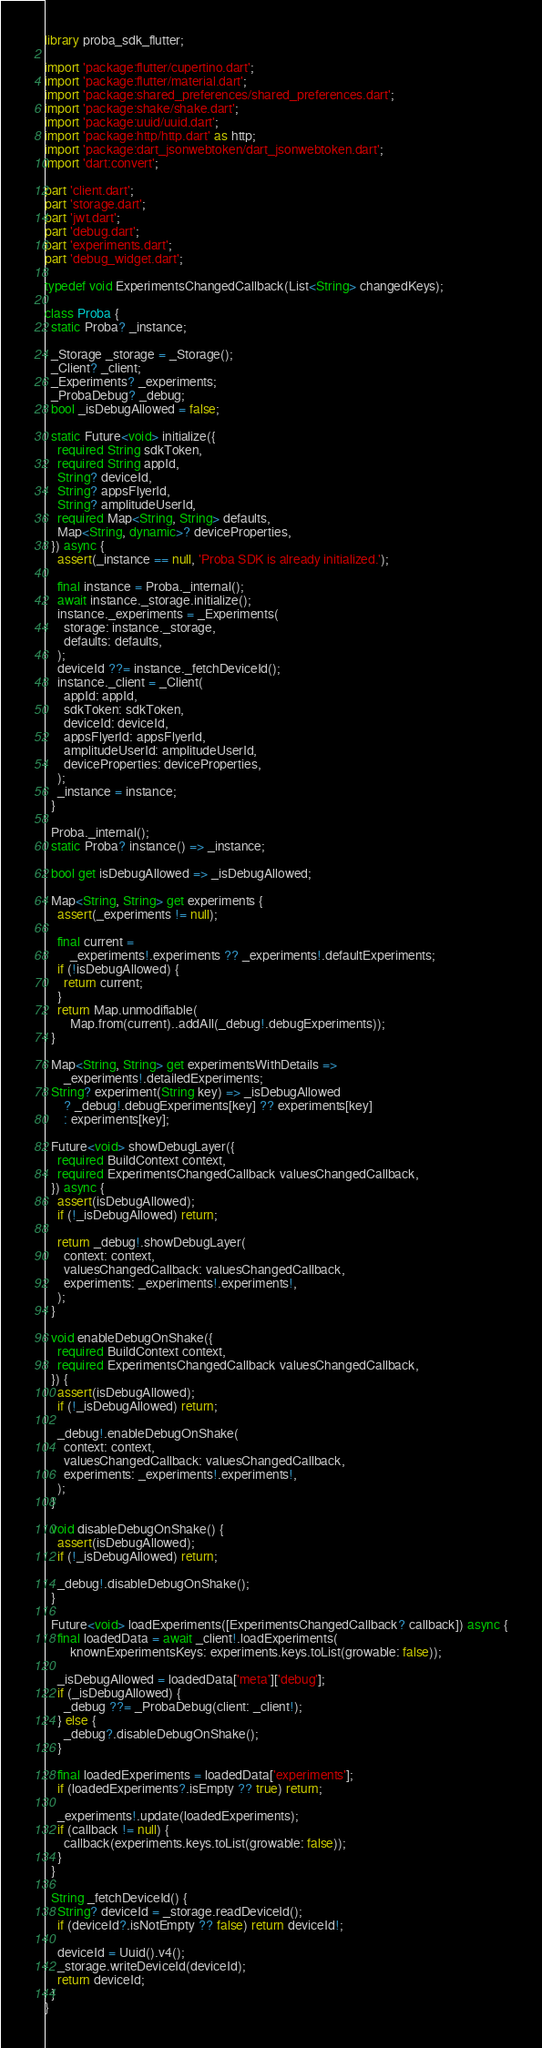Convert code to text. <code><loc_0><loc_0><loc_500><loc_500><_Dart_>library proba_sdk_flutter;

import 'package:flutter/cupertino.dart';
import 'package:flutter/material.dart';
import 'package:shared_preferences/shared_preferences.dart';
import 'package:shake/shake.dart';
import 'package:uuid/uuid.dart';
import 'package:http/http.dart' as http;
import 'package:dart_jsonwebtoken/dart_jsonwebtoken.dart';
import 'dart:convert';

part 'client.dart';
part 'storage.dart';
part 'jwt.dart';
part 'debug.dart';
part 'experiments.dart';
part 'debug_widget.dart';

typedef void ExperimentsChangedCallback(List<String> changedKeys);

class Proba {
  static Proba? _instance;

  _Storage _storage = _Storage();
  _Client? _client;
  _Experiments? _experiments;
  _ProbaDebug? _debug;
  bool _isDebugAllowed = false;

  static Future<void> initialize({
    required String sdkToken,
    required String appId,
    String? deviceId,
    String? appsFlyerId,
    String? amplitudeUserId,
    required Map<String, String> defaults,
    Map<String, dynamic>? deviceProperties,
  }) async {
    assert(_instance == null, 'Proba SDK is already initialized.');

    final instance = Proba._internal();
    await instance._storage.initialize();
    instance._experiments = _Experiments(
      storage: instance._storage,
      defaults: defaults,
    );
    deviceId ??= instance._fetchDeviceId();
    instance._client = _Client(
      appId: appId,
      sdkToken: sdkToken,
      deviceId: deviceId,
      appsFlyerId: appsFlyerId,
      amplitudeUserId: amplitudeUserId,
      deviceProperties: deviceProperties,
    );
    _instance = instance;
  }

  Proba._internal();
  static Proba? instance() => _instance;

  bool get isDebugAllowed => _isDebugAllowed;

  Map<String, String> get experiments {
    assert(_experiments != null);

    final current =
        _experiments!.experiments ?? _experiments!.defaultExperiments;
    if (!isDebugAllowed) {
      return current;
    }
    return Map.unmodifiable(
        Map.from(current)..addAll(_debug!.debugExperiments));
  }

  Map<String, String> get experimentsWithDetails =>
      _experiments!.detailedExperiments;
  String? experiment(String key) => _isDebugAllowed
      ? _debug!.debugExperiments[key] ?? experiments[key]
      : experiments[key];

  Future<void> showDebugLayer({
    required BuildContext context,
    required ExperimentsChangedCallback valuesChangedCallback,
  }) async {
    assert(isDebugAllowed);
    if (!_isDebugAllowed) return;

    return _debug!.showDebugLayer(
      context: context,
      valuesChangedCallback: valuesChangedCallback,
      experiments: _experiments!.experiments!,
    );
  }

  void enableDebugOnShake({
    required BuildContext context,
    required ExperimentsChangedCallback valuesChangedCallback,
  }) {
    assert(isDebugAllowed);
    if (!_isDebugAllowed) return;

    _debug!.enableDebugOnShake(
      context: context,
      valuesChangedCallback: valuesChangedCallback,
      experiments: _experiments!.experiments!,
    );
  }

  void disableDebugOnShake() {
    assert(isDebugAllowed);
    if (!_isDebugAllowed) return;

    _debug!.disableDebugOnShake();
  }

  Future<void> loadExperiments([ExperimentsChangedCallback? callback]) async {
    final loadedData = await _client!.loadExperiments(
        knownExperimentsKeys: experiments.keys.toList(growable: false));

    _isDebugAllowed = loadedData['meta']['debug'];
    if (_isDebugAllowed) {
      _debug ??= _ProbaDebug(client: _client!);
    } else {
      _debug?.disableDebugOnShake();
    }

    final loadedExperiments = loadedData['experiments'];
    if (loadedExperiments?.isEmpty ?? true) return;

    _experiments!.update(loadedExperiments);
    if (callback != null) {
      callback(experiments.keys.toList(growable: false));
    }
  }

  String _fetchDeviceId() {
    String? deviceId = _storage.readDeviceId();
    if (deviceId?.isNotEmpty ?? false) return deviceId!;

    deviceId = Uuid().v4();
    _storage.writeDeviceId(deviceId);
    return deviceId;
  }
}
</code> 